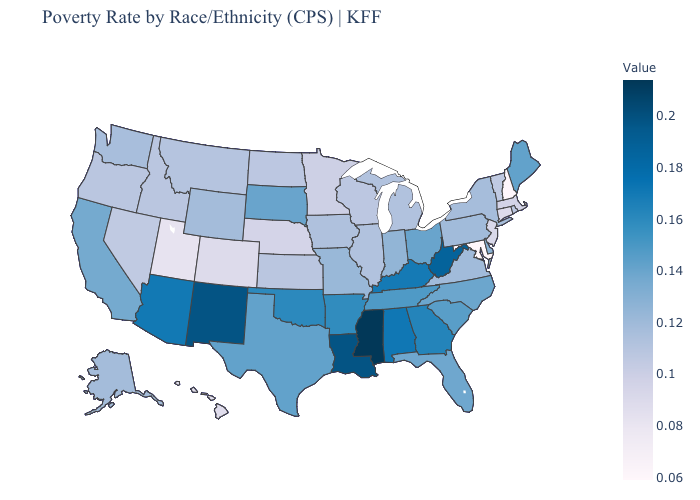Which states have the highest value in the USA?
Answer briefly. Mississippi. Which states have the highest value in the USA?
Give a very brief answer. Mississippi. Which states hav the highest value in the MidWest?
Short answer required. Ohio, South Dakota. Does the map have missing data?
Keep it brief. No. Does Tennessee have a lower value than West Virginia?
Answer briefly. Yes. Does South Dakota have a lower value than Colorado?
Short answer required. No. Among the states that border Indiana , does Illinois have the lowest value?
Write a very short answer. Yes. 